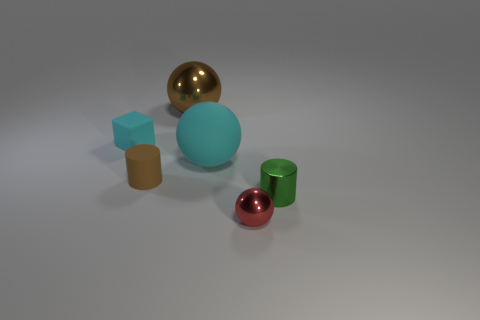Add 3 tiny green metallic cylinders. How many objects exist? 9 Subtract all blocks. How many objects are left? 5 Add 5 brown metal cubes. How many brown metal cubes exist? 5 Subtract 0 yellow spheres. How many objects are left? 6 Subtract all brown rubber objects. Subtract all shiny spheres. How many objects are left? 3 Add 1 green metallic things. How many green metallic things are left? 2 